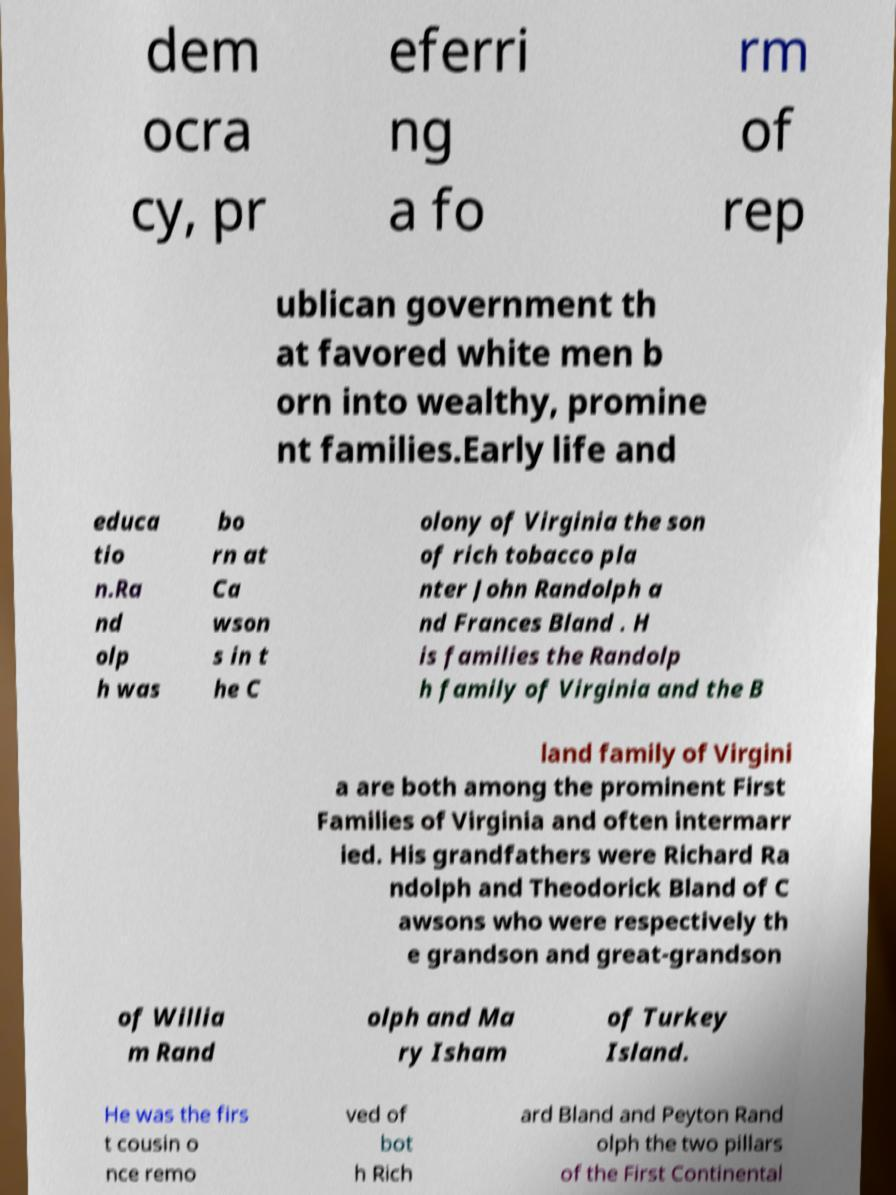I need the written content from this picture converted into text. Can you do that? dem ocra cy, pr eferri ng a fo rm of rep ublican government th at favored white men b orn into wealthy, promine nt families.Early life and educa tio n.Ra nd olp h was bo rn at Ca wson s in t he C olony of Virginia the son of rich tobacco pla nter John Randolph a nd Frances Bland . H is families the Randolp h family of Virginia and the B land family of Virgini a are both among the prominent First Families of Virginia and often intermarr ied. His grandfathers were Richard Ra ndolph and Theodorick Bland of C awsons who were respectively th e grandson and great-grandson of Willia m Rand olph and Ma ry Isham of Turkey Island. He was the firs t cousin o nce remo ved of bot h Rich ard Bland and Peyton Rand olph the two pillars of the First Continental 